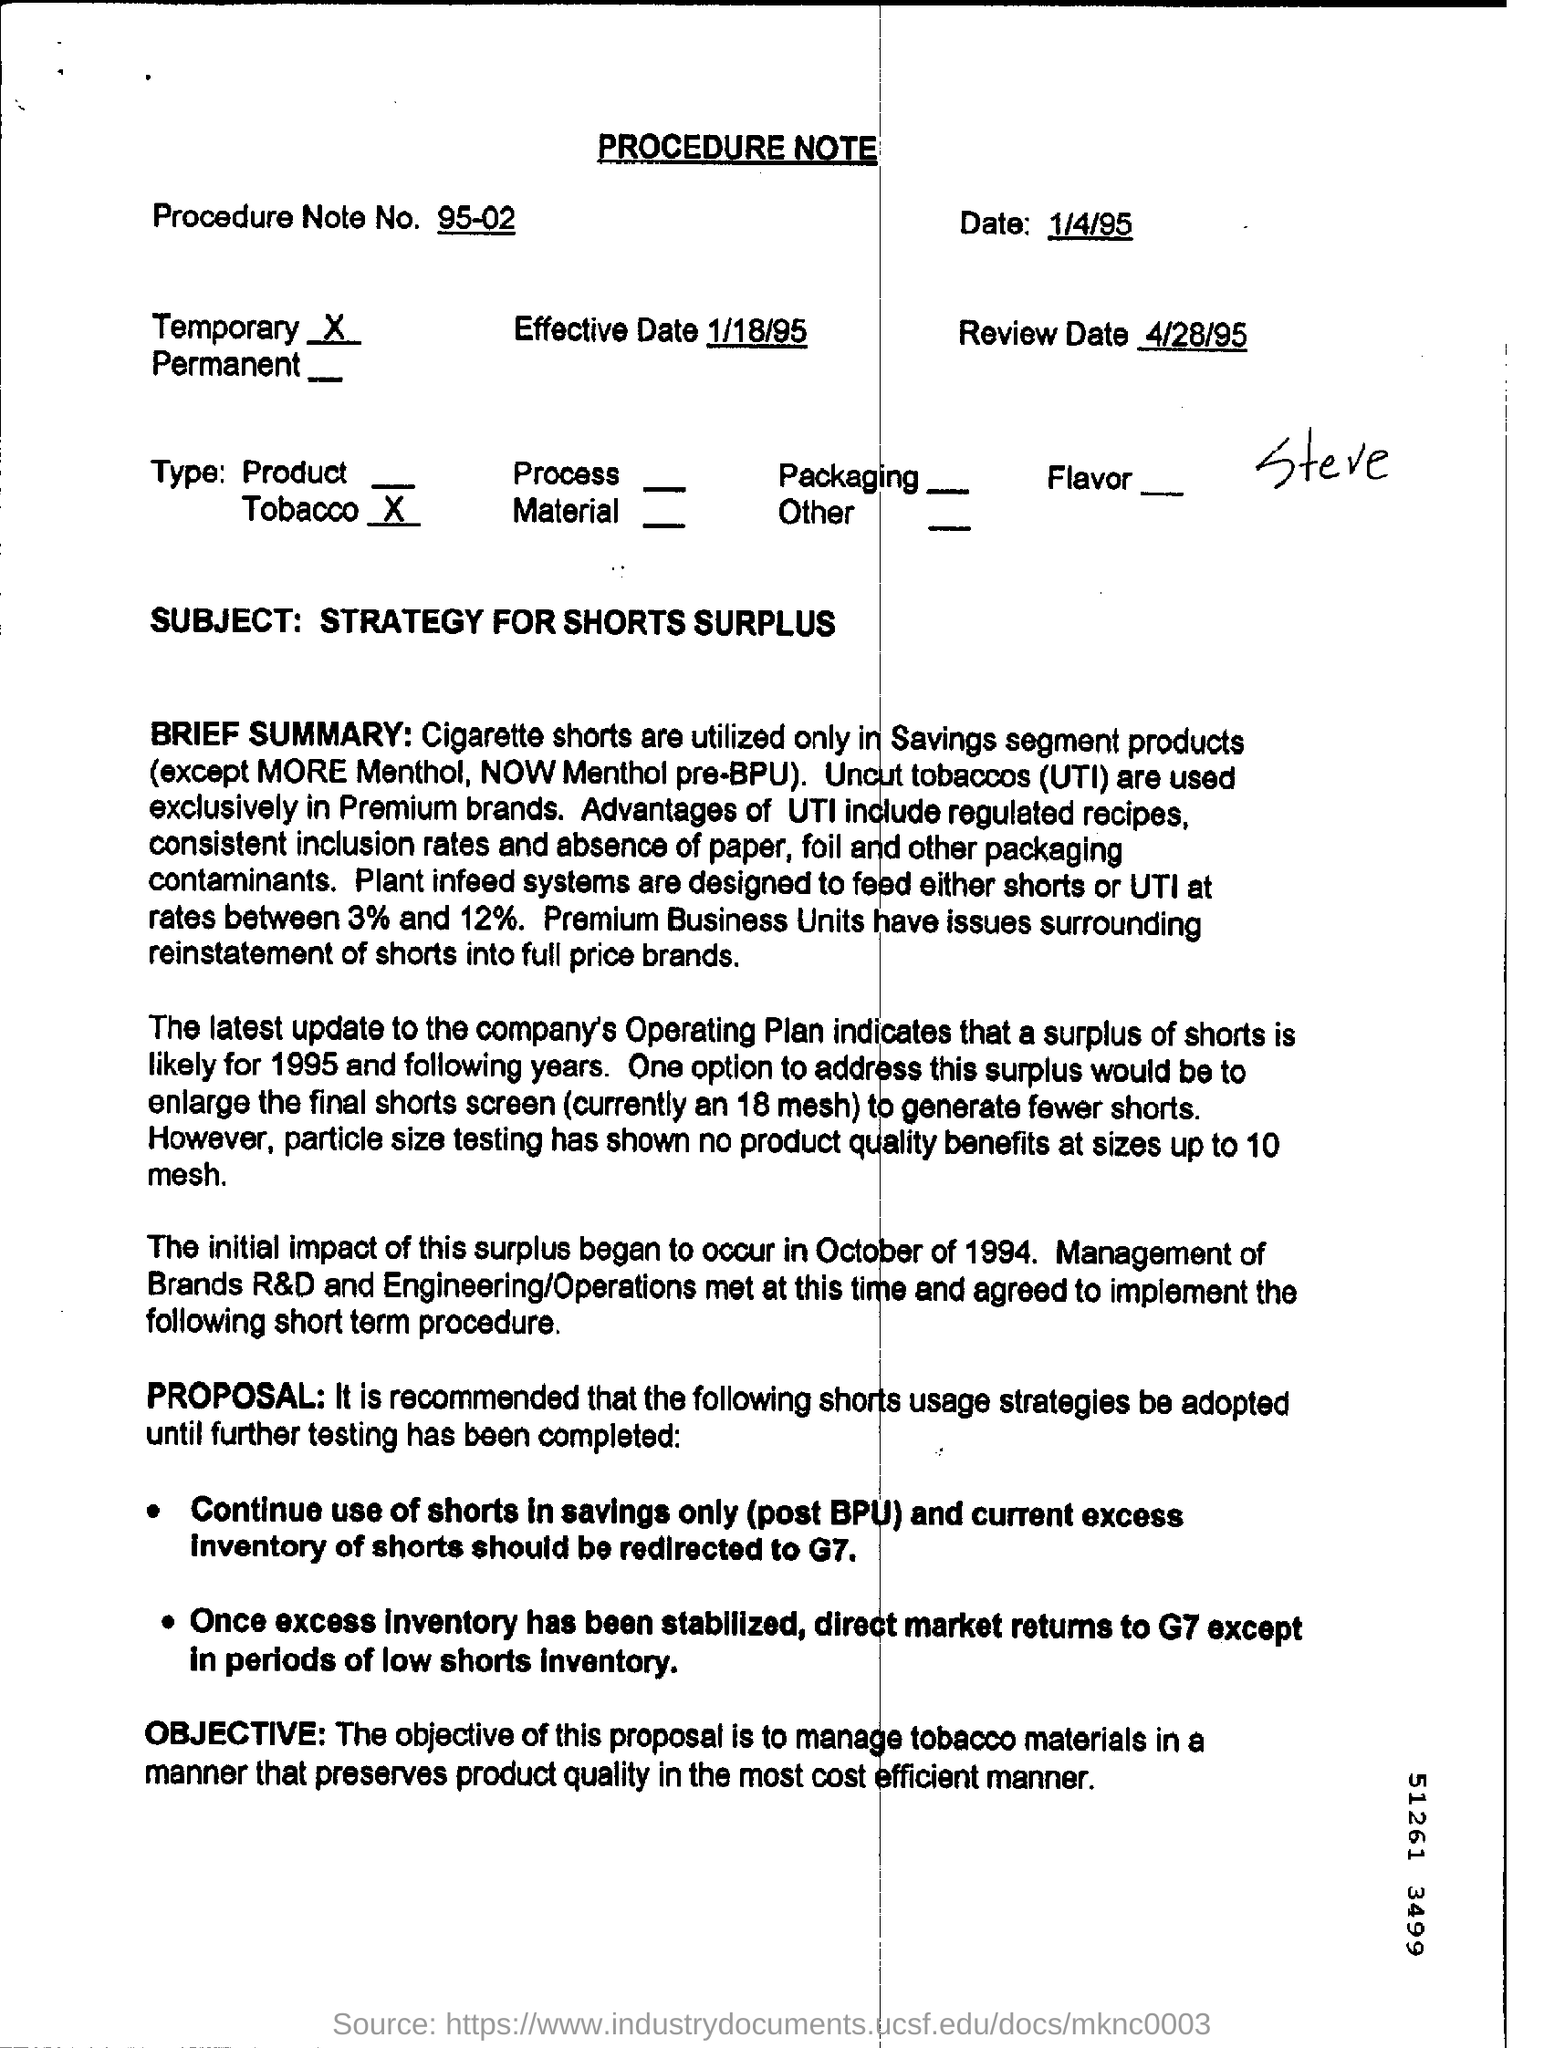What is the procedure note no.?
Provide a succinct answer. 95-02. When is the review?
Provide a short and direct response. 4/28/95. What does UTI mean?
Ensure brevity in your answer.  Uncut Tobaccos. At what rates are plant infeed systems designed to feed either shorts or UTI?
Your response must be concise. Between 3% and 12%. What is the Procedure Note No?
Give a very brief answer. 95-02. What is the current size of the final shorts screen?
Your answer should be very brief. 18 mesh. 